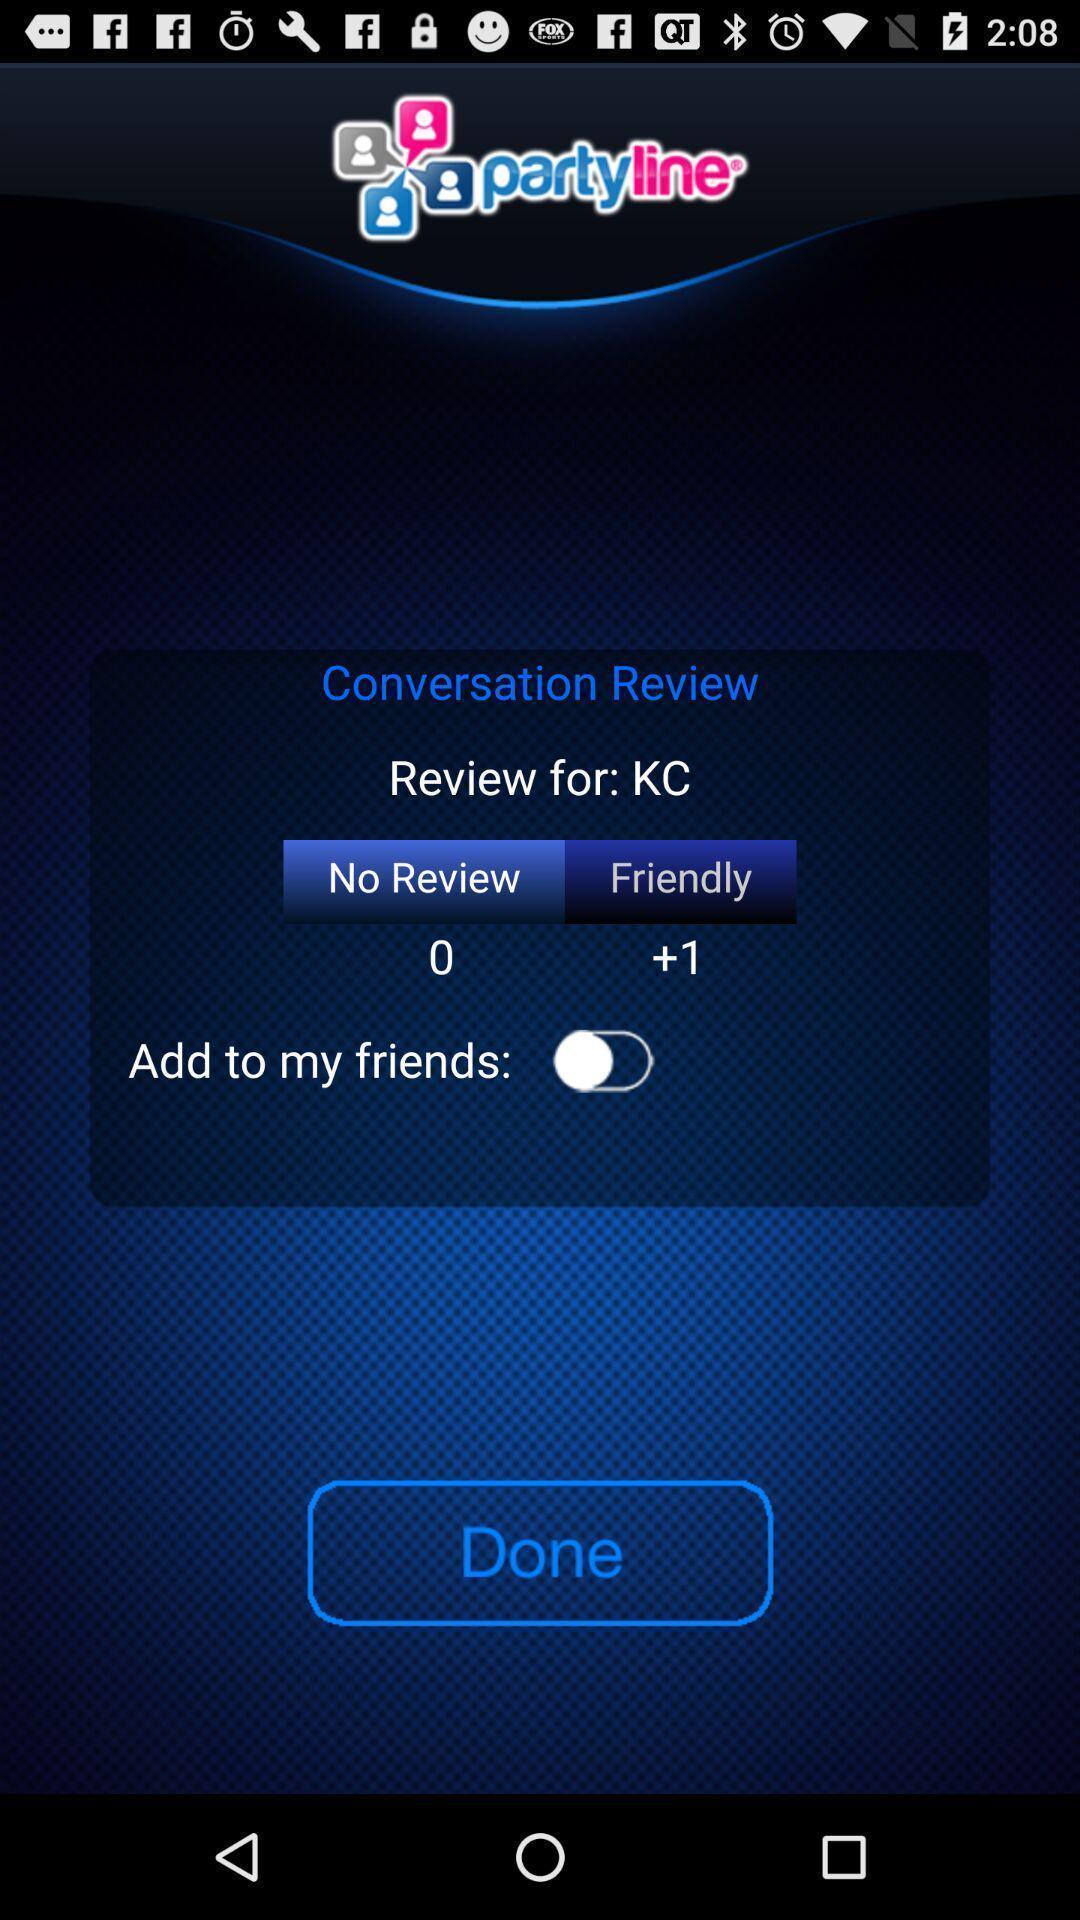Provide a detailed account of this screenshot. Review page displaying in application. 